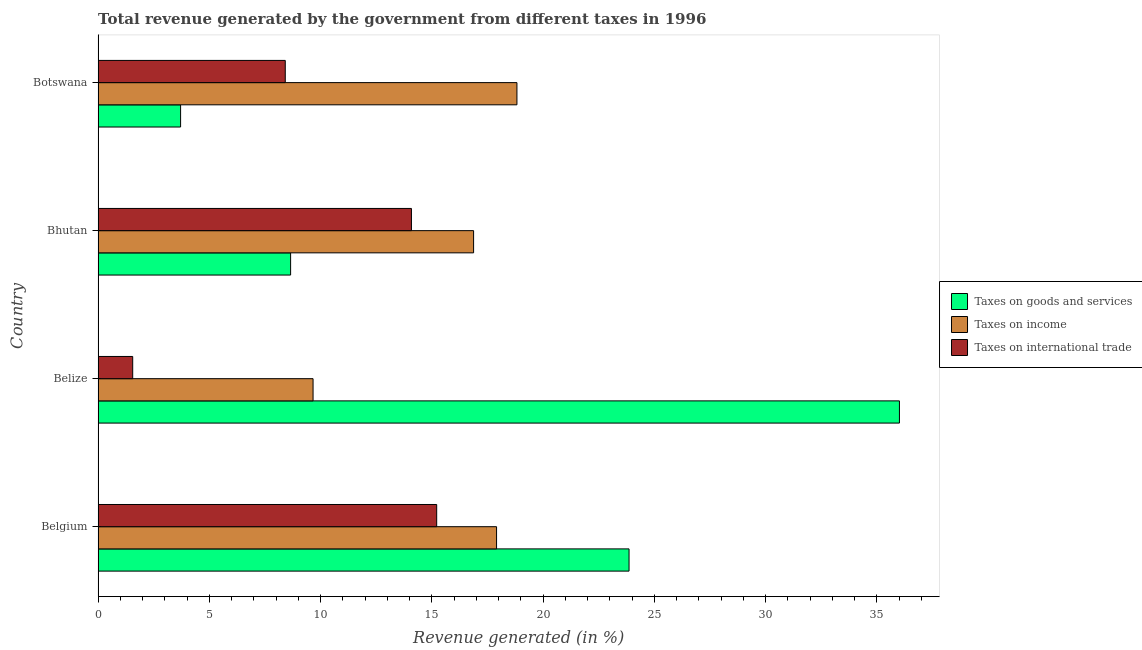How many different coloured bars are there?
Your response must be concise. 3. Are the number of bars on each tick of the Y-axis equal?
Provide a succinct answer. Yes. How many bars are there on the 1st tick from the top?
Your answer should be very brief. 3. What is the label of the 2nd group of bars from the top?
Your response must be concise. Bhutan. What is the percentage of revenue generated by taxes on goods and services in Botswana?
Your answer should be compact. 3.71. Across all countries, what is the maximum percentage of revenue generated by taxes on income?
Make the answer very short. 18.82. Across all countries, what is the minimum percentage of revenue generated by taxes on goods and services?
Your answer should be compact. 3.71. In which country was the percentage of revenue generated by taxes on income maximum?
Provide a short and direct response. Botswana. In which country was the percentage of revenue generated by tax on international trade minimum?
Ensure brevity in your answer.  Belize. What is the total percentage of revenue generated by taxes on goods and services in the graph?
Your answer should be compact. 72.24. What is the difference between the percentage of revenue generated by taxes on goods and services in Belize and that in Bhutan?
Provide a succinct answer. 27.36. What is the difference between the percentage of revenue generated by taxes on income in Belgium and the percentage of revenue generated by tax on international trade in Belize?
Offer a terse response. 16.35. What is the average percentage of revenue generated by taxes on income per country?
Keep it short and to the point. 15.82. What is the difference between the percentage of revenue generated by taxes on goods and services and percentage of revenue generated by tax on international trade in Bhutan?
Ensure brevity in your answer.  -5.43. In how many countries, is the percentage of revenue generated by taxes on goods and services greater than 17 %?
Keep it short and to the point. 2. What is the ratio of the percentage of revenue generated by taxes on income in Belgium to that in Bhutan?
Provide a short and direct response. 1.06. Is the difference between the percentage of revenue generated by tax on international trade in Belgium and Botswana greater than the difference between the percentage of revenue generated by taxes on income in Belgium and Botswana?
Provide a short and direct response. Yes. What is the difference between the highest and the second highest percentage of revenue generated by taxes on goods and services?
Ensure brevity in your answer.  12.15. What is the difference between the highest and the lowest percentage of revenue generated by taxes on income?
Provide a short and direct response. 9.16. Is the sum of the percentage of revenue generated by tax on international trade in Bhutan and Botswana greater than the maximum percentage of revenue generated by taxes on goods and services across all countries?
Offer a very short reply. No. What does the 1st bar from the top in Bhutan represents?
Give a very brief answer. Taxes on international trade. What does the 1st bar from the bottom in Bhutan represents?
Keep it short and to the point. Taxes on goods and services. Is it the case that in every country, the sum of the percentage of revenue generated by taxes on goods and services and percentage of revenue generated by taxes on income is greater than the percentage of revenue generated by tax on international trade?
Make the answer very short. Yes. How many bars are there?
Give a very brief answer. 12. Are all the bars in the graph horizontal?
Give a very brief answer. Yes. How many countries are there in the graph?
Offer a terse response. 4. Are the values on the major ticks of X-axis written in scientific E-notation?
Offer a very short reply. No. Does the graph contain grids?
Your response must be concise. No. How many legend labels are there?
Offer a terse response. 3. How are the legend labels stacked?
Your response must be concise. Vertical. What is the title of the graph?
Provide a short and direct response. Total revenue generated by the government from different taxes in 1996. Does "Secondary education" appear as one of the legend labels in the graph?
Your answer should be compact. No. What is the label or title of the X-axis?
Provide a short and direct response. Revenue generated (in %). What is the Revenue generated (in %) in Taxes on goods and services in Belgium?
Give a very brief answer. 23.86. What is the Revenue generated (in %) of Taxes on income in Belgium?
Keep it short and to the point. 17.91. What is the Revenue generated (in %) of Taxes on international trade in Belgium?
Your answer should be compact. 15.22. What is the Revenue generated (in %) of Taxes on goods and services in Belize?
Give a very brief answer. 36.01. What is the Revenue generated (in %) in Taxes on income in Belize?
Ensure brevity in your answer.  9.66. What is the Revenue generated (in %) of Taxes on international trade in Belize?
Keep it short and to the point. 1.56. What is the Revenue generated (in %) of Taxes on goods and services in Bhutan?
Keep it short and to the point. 8.65. What is the Revenue generated (in %) of Taxes on income in Bhutan?
Offer a terse response. 16.88. What is the Revenue generated (in %) of Taxes on international trade in Bhutan?
Your answer should be compact. 14.08. What is the Revenue generated (in %) in Taxes on goods and services in Botswana?
Provide a succinct answer. 3.71. What is the Revenue generated (in %) in Taxes on income in Botswana?
Offer a terse response. 18.82. What is the Revenue generated (in %) of Taxes on international trade in Botswana?
Provide a succinct answer. 8.41. Across all countries, what is the maximum Revenue generated (in %) of Taxes on goods and services?
Offer a very short reply. 36.01. Across all countries, what is the maximum Revenue generated (in %) in Taxes on income?
Provide a short and direct response. 18.82. Across all countries, what is the maximum Revenue generated (in %) of Taxes on international trade?
Your response must be concise. 15.22. Across all countries, what is the minimum Revenue generated (in %) in Taxes on goods and services?
Make the answer very short. 3.71. Across all countries, what is the minimum Revenue generated (in %) in Taxes on income?
Offer a very short reply. 9.66. Across all countries, what is the minimum Revenue generated (in %) of Taxes on international trade?
Your answer should be compact. 1.56. What is the total Revenue generated (in %) of Taxes on goods and services in the graph?
Offer a very short reply. 72.24. What is the total Revenue generated (in %) of Taxes on income in the graph?
Give a very brief answer. 63.27. What is the total Revenue generated (in %) in Taxes on international trade in the graph?
Provide a succinct answer. 39.27. What is the difference between the Revenue generated (in %) in Taxes on goods and services in Belgium and that in Belize?
Your answer should be very brief. -12.15. What is the difference between the Revenue generated (in %) in Taxes on income in Belgium and that in Belize?
Provide a short and direct response. 8.25. What is the difference between the Revenue generated (in %) of Taxes on international trade in Belgium and that in Belize?
Give a very brief answer. 13.66. What is the difference between the Revenue generated (in %) in Taxes on goods and services in Belgium and that in Bhutan?
Offer a terse response. 15.21. What is the difference between the Revenue generated (in %) in Taxes on income in Belgium and that in Bhutan?
Your answer should be very brief. 1.03. What is the difference between the Revenue generated (in %) in Taxes on international trade in Belgium and that in Bhutan?
Offer a very short reply. 1.14. What is the difference between the Revenue generated (in %) of Taxes on goods and services in Belgium and that in Botswana?
Provide a succinct answer. 20.15. What is the difference between the Revenue generated (in %) of Taxes on income in Belgium and that in Botswana?
Your answer should be very brief. -0.92. What is the difference between the Revenue generated (in %) of Taxes on international trade in Belgium and that in Botswana?
Provide a short and direct response. 6.81. What is the difference between the Revenue generated (in %) of Taxes on goods and services in Belize and that in Bhutan?
Offer a terse response. 27.36. What is the difference between the Revenue generated (in %) of Taxes on income in Belize and that in Bhutan?
Provide a short and direct response. -7.21. What is the difference between the Revenue generated (in %) in Taxes on international trade in Belize and that in Bhutan?
Keep it short and to the point. -12.53. What is the difference between the Revenue generated (in %) of Taxes on goods and services in Belize and that in Botswana?
Your response must be concise. 32.31. What is the difference between the Revenue generated (in %) of Taxes on income in Belize and that in Botswana?
Provide a succinct answer. -9.16. What is the difference between the Revenue generated (in %) in Taxes on international trade in Belize and that in Botswana?
Offer a very short reply. -6.86. What is the difference between the Revenue generated (in %) of Taxes on goods and services in Bhutan and that in Botswana?
Your answer should be very brief. 4.94. What is the difference between the Revenue generated (in %) of Taxes on income in Bhutan and that in Botswana?
Keep it short and to the point. -1.95. What is the difference between the Revenue generated (in %) in Taxes on international trade in Bhutan and that in Botswana?
Make the answer very short. 5.67. What is the difference between the Revenue generated (in %) of Taxes on goods and services in Belgium and the Revenue generated (in %) of Taxes on income in Belize?
Offer a terse response. 14.2. What is the difference between the Revenue generated (in %) in Taxes on goods and services in Belgium and the Revenue generated (in %) in Taxes on international trade in Belize?
Offer a terse response. 22.31. What is the difference between the Revenue generated (in %) of Taxes on income in Belgium and the Revenue generated (in %) of Taxes on international trade in Belize?
Offer a terse response. 16.35. What is the difference between the Revenue generated (in %) in Taxes on goods and services in Belgium and the Revenue generated (in %) in Taxes on income in Bhutan?
Ensure brevity in your answer.  6.99. What is the difference between the Revenue generated (in %) in Taxes on goods and services in Belgium and the Revenue generated (in %) in Taxes on international trade in Bhutan?
Make the answer very short. 9.78. What is the difference between the Revenue generated (in %) of Taxes on income in Belgium and the Revenue generated (in %) of Taxes on international trade in Bhutan?
Ensure brevity in your answer.  3.83. What is the difference between the Revenue generated (in %) of Taxes on goods and services in Belgium and the Revenue generated (in %) of Taxes on income in Botswana?
Provide a succinct answer. 5.04. What is the difference between the Revenue generated (in %) of Taxes on goods and services in Belgium and the Revenue generated (in %) of Taxes on international trade in Botswana?
Provide a short and direct response. 15.45. What is the difference between the Revenue generated (in %) of Taxes on income in Belgium and the Revenue generated (in %) of Taxes on international trade in Botswana?
Your answer should be very brief. 9.5. What is the difference between the Revenue generated (in %) of Taxes on goods and services in Belize and the Revenue generated (in %) of Taxes on income in Bhutan?
Your answer should be compact. 19.14. What is the difference between the Revenue generated (in %) in Taxes on goods and services in Belize and the Revenue generated (in %) in Taxes on international trade in Bhutan?
Keep it short and to the point. 21.93. What is the difference between the Revenue generated (in %) in Taxes on income in Belize and the Revenue generated (in %) in Taxes on international trade in Bhutan?
Your answer should be very brief. -4.42. What is the difference between the Revenue generated (in %) in Taxes on goods and services in Belize and the Revenue generated (in %) in Taxes on income in Botswana?
Provide a succinct answer. 17.19. What is the difference between the Revenue generated (in %) in Taxes on goods and services in Belize and the Revenue generated (in %) in Taxes on international trade in Botswana?
Provide a succinct answer. 27.6. What is the difference between the Revenue generated (in %) in Taxes on income in Belize and the Revenue generated (in %) in Taxes on international trade in Botswana?
Provide a short and direct response. 1.25. What is the difference between the Revenue generated (in %) in Taxes on goods and services in Bhutan and the Revenue generated (in %) in Taxes on income in Botswana?
Give a very brief answer. -10.17. What is the difference between the Revenue generated (in %) in Taxes on goods and services in Bhutan and the Revenue generated (in %) in Taxes on international trade in Botswana?
Provide a succinct answer. 0.24. What is the difference between the Revenue generated (in %) of Taxes on income in Bhutan and the Revenue generated (in %) of Taxes on international trade in Botswana?
Your answer should be very brief. 8.46. What is the average Revenue generated (in %) of Taxes on goods and services per country?
Your response must be concise. 18.06. What is the average Revenue generated (in %) in Taxes on income per country?
Provide a short and direct response. 15.82. What is the average Revenue generated (in %) of Taxes on international trade per country?
Your response must be concise. 9.82. What is the difference between the Revenue generated (in %) in Taxes on goods and services and Revenue generated (in %) in Taxes on income in Belgium?
Provide a short and direct response. 5.95. What is the difference between the Revenue generated (in %) in Taxes on goods and services and Revenue generated (in %) in Taxes on international trade in Belgium?
Give a very brief answer. 8.64. What is the difference between the Revenue generated (in %) in Taxes on income and Revenue generated (in %) in Taxes on international trade in Belgium?
Give a very brief answer. 2.69. What is the difference between the Revenue generated (in %) in Taxes on goods and services and Revenue generated (in %) in Taxes on income in Belize?
Give a very brief answer. 26.35. What is the difference between the Revenue generated (in %) in Taxes on goods and services and Revenue generated (in %) in Taxes on international trade in Belize?
Keep it short and to the point. 34.46. What is the difference between the Revenue generated (in %) of Taxes on income and Revenue generated (in %) of Taxes on international trade in Belize?
Make the answer very short. 8.11. What is the difference between the Revenue generated (in %) in Taxes on goods and services and Revenue generated (in %) in Taxes on income in Bhutan?
Keep it short and to the point. -8.22. What is the difference between the Revenue generated (in %) of Taxes on goods and services and Revenue generated (in %) of Taxes on international trade in Bhutan?
Give a very brief answer. -5.43. What is the difference between the Revenue generated (in %) of Taxes on income and Revenue generated (in %) of Taxes on international trade in Bhutan?
Give a very brief answer. 2.79. What is the difference between the Revenue generated (in %) of Taxes on goods and services and Revenue generated (in %) of Taxes on income in Botswana?
Provide a short and direct response. -15.12. What is the difference between the Revenue generated (in %) in Taxes on goods and services and Revenue generated (in %) in Taxes on international trade in Botswana?
Provide a short and direct response. -4.7. What is the difference between the Revenue generated (in %) in Taxes on income and Revenue generated (in %) in Taxes on international trade in Botswana?
Give a very brief answer. 10.41. What is the ratio of the Revenue generated (in %) in Taxes on goods and services in Belgium to that in Belize?
Keep it short and to the point. 0.66. What is the ratio of the Revenue generated (in %) in Taxes on income in Belgium to that in Belize?
Provide a short and direct response. 1.85. What is the ratio of the Revenue generated (in %) of Taxes on international trade in Belgium to that in Belize?
Keep it short and to the point. 9.78. What is the ratio of the Revenue generated (in %) of Taxes on goods and services in Belgium to that in Bhutan?
Give a very brief answer. 2.76. What is the ratio of the Revenue generated (in %) of Taxes on income in Belgium to that in Bhutan?
Ensure brevity in your answer.  1.06. What is the ratio of the Revenue generated (in %) in Taxes on international trade in Belgium to that in Bhutan?
Keep it short and to the point. 1.08. What is the ratio of the Revenue generated (in %) of Taxes on goods and services in Belgium to that in Botswana?
Offer a very short reply. 6.43. What is the ratio of the Revenue generated (in %) in Taxes on income in Belgium to that in Botswana?
Offer a very short reply. 0.95. What is the ratio of the Revenue generated (in %) in Taxes on international trade in Belgium to that in Botswana?
Keep it short and to the point. 1.81. What is the ratio of the Revenue generated (in %) of Taxes on goods and services in Belize to that in Bhutan?
Your response must be concise. 4.16. What is the ratio of the Revenue generated (in %) of Taxes on income in Belize to that in Bhutan?
Make the answer very short. 0.57. What is the ratio of the Revenue generated (in %) in Taxes on international trade in Belize to that in Bhutan?
Ensure brevity in your answer.  0.11. What is the ratio of the Revenue generated (in %) of Taxes on goods and services in Belize to that in Botswana?
Offer a very short reply. 9.71. What is the ratio of the Revenue generated (in %) of Taxes on income in Belize to that in Botswana?
Provide a succinct answer. 0.51. What is the ratio of the Revenue generated (in %) in Taxes on international trade in Belize to that in Botswana?
Ensure brevity in your answer.  0.18. What is the ratio of the Revenue generated (in %) of Taxes on goods and services in Bhutan to that in Botswana?
Keep it short and to the point. 2.33. What is the ratio of the Revenue generated (in %) of Taxes on income in Bhutan to that in Botswana?
Provide a short and direct response. 0.9. What is the ratio of the Revenue generated (in %) in Taxes on international trade in Bhutan to that in Botswana?
Your answer should be compact. 1.67. What is the difference between the highest and the second highest Revenue generated (in %) of Taxes on goods and services?
Ensure brevity in your answer.  12.15. What is the difference between the highest and the second highest Revenue generated (in %) of Taxes on income?
Your answer should be very brief. 0.92. What is the difference between the highest and the second highest Revenue generated (in %) in Taxes on international trade?
Keep it short and to the point. 1.14. What is the difference between the highest and the lowest Revenue generated (in %) of Taxes on goods and services?
Offer a very short reply. 32.31. What is the difference between the highest and the lowest Revenue generated (in %) in Taxes on income?
Provide a succinct answer. 9.16. What is the difference between the highest and the lowest Revenue generated (in %) in Taxes on international trade?
Offer a terse response. 13.66. 